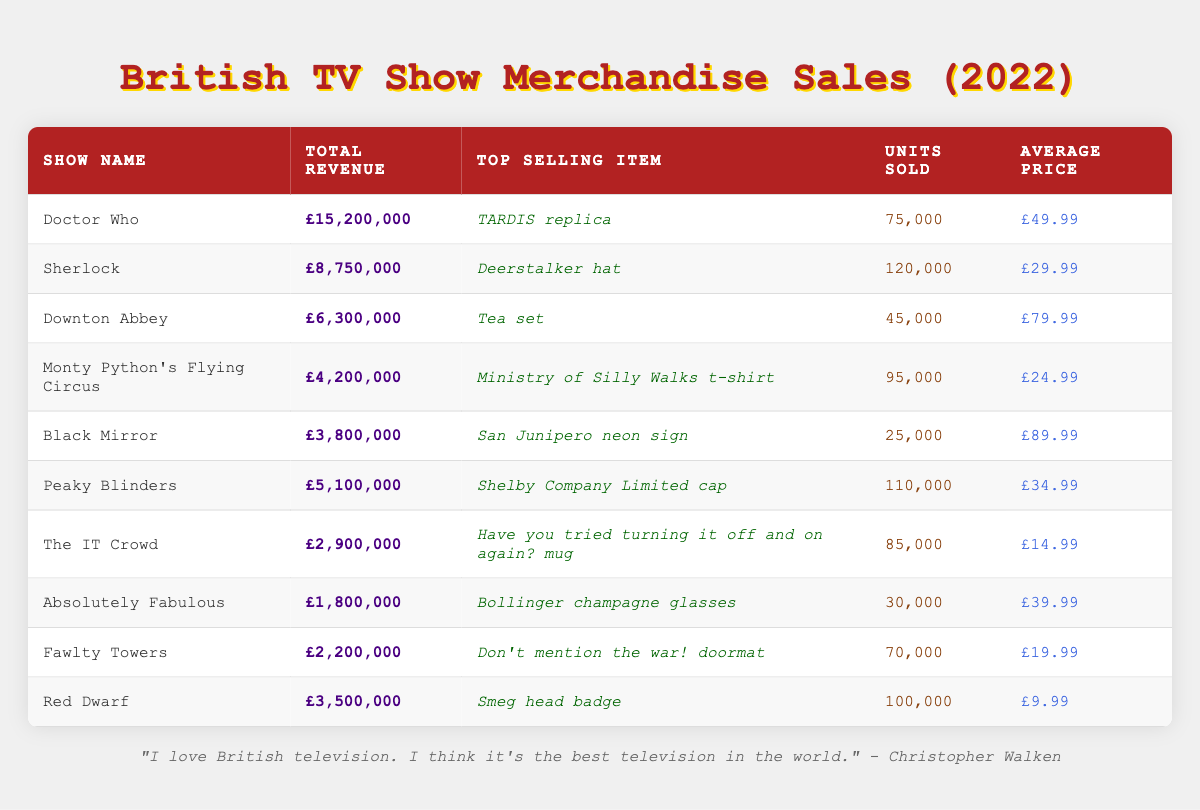What is the top selling item for Doctor Who? According to the table, the top selling item under the Doctor Who row is the "TARDIS replica."
Answer: TARDIS replica Which British TV show had the highest total revenue in 2022? By comparing the total revenue columns, Doctor Who shows the highest revenue amount of £15,200,000, making it the highest among all listed shows.
Answer: Doctor Who How many units of the Deerstalker hat were sold? The table indicates that 120,000 units of the Deerstalker hat were sold for the show Sherlock in 2022.
Answer: 120,000 What is the average price of items sold for Downton Abbey? The average price for Downton Abbey is listed as £79.99, as seen directly in the corresponding row of the table.
Answer: £79.99 Which show had total revenue less than £3 million? By examining the table, the total revenues for Absolutely Fabulous (£1,800,000) and The IT Crowd (£2,900,000) are both less than £3 million.
Answer: Yes What is the difference in total revenue between Peaky Blinders and Monty Python's Flying Circus? The total revenue for Peaky Blinders is £5,100,000 and for Monty Python's Flying Circus is £4,200,000. The difference is £5,100,000 - £4,200,000 = £900,000.
Answer: £900,000 Did Black Mirror sell more than 50,000 units of its top selling item? The table shows that Black Mirror sold only 25,000 units of the San Junipero neon sign, which is less than 50,000.
Answer: No What is the average total revenue for the sitcoms on this list? The sitcoms listed are The IT Crowd, Absolutely Fabulous, and Fawlty Towers. The total revenues for these shows are £2,900,000 + £1,800,000 + £2,200,000 = £6,900,000. The average is £6,900,000 / 3 = £2,300,000.
Answer: £2,300,000 Which item had the highest average price and what was that price? By examining the average price against each top selling item in the table, the San Junipero neon sign reaches an average price of £89.99, making it the highest priced item.
Answer: £89.99 